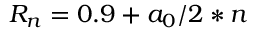Convert formula to latex. <formula><loc_0><loc_0><loc_500><loc_500>R _ { n } = 0 . 9 + a _ { 0 } / 2 * n</formula> 